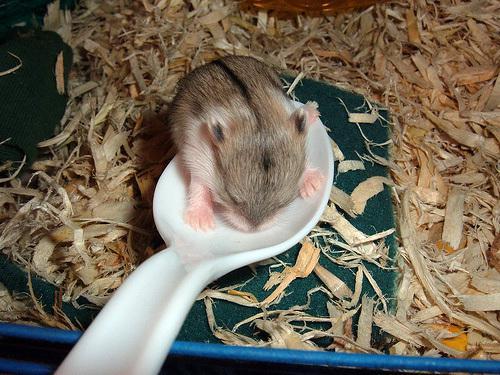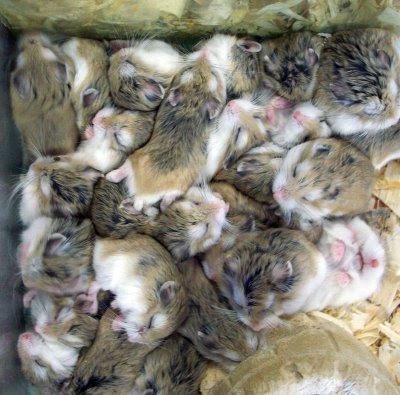The first image is the image on the left, the second image is the image on the right. Assess this claim about the two images: "More than five rodents are positioned in the woodchips and mulch.". Correct or not? Answer yes or no. Yes. The first image is the image on the left, the second image is the image on the right. Evaluate the accuracy of this statement regarding the images: "A rodent's face is seen through a hole in one image.". Is it true? Answer yes or no. No. 